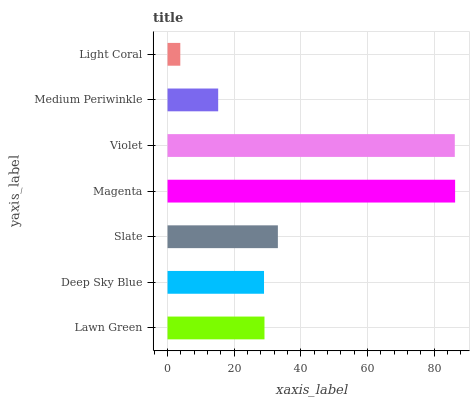Is Light Coral the minimum?
Answer yes or no. Yes. Is Magenta the maximum?
Answer yes or no. Yes. Is Deep Sky Blue the minimum?
Answer yes or no. No. Is Deep Sky Blue the maximum?
Answer yes or no. No. Is Lawn Green greater than Deep Sky Blue?
Answer yes or no. Yes. Is Deep Sky Blue less than Lawn Green?
Answer yes or no. Yes. Is Deep Sky Blue greater than Lawn Green?
Answer yes or no. No. Is Lawn Green less than Deep Sky Blue?
Answer yes or no. No. Is Lawn Green the high median?
Answer yes or no. Yes. Is Lawn Green the low median?
Answer yes or no. Yes. Is Slate the high median?
Answer yes or no. No. Is Deep Sky Blue the low median?
Answer yes or no. No. 